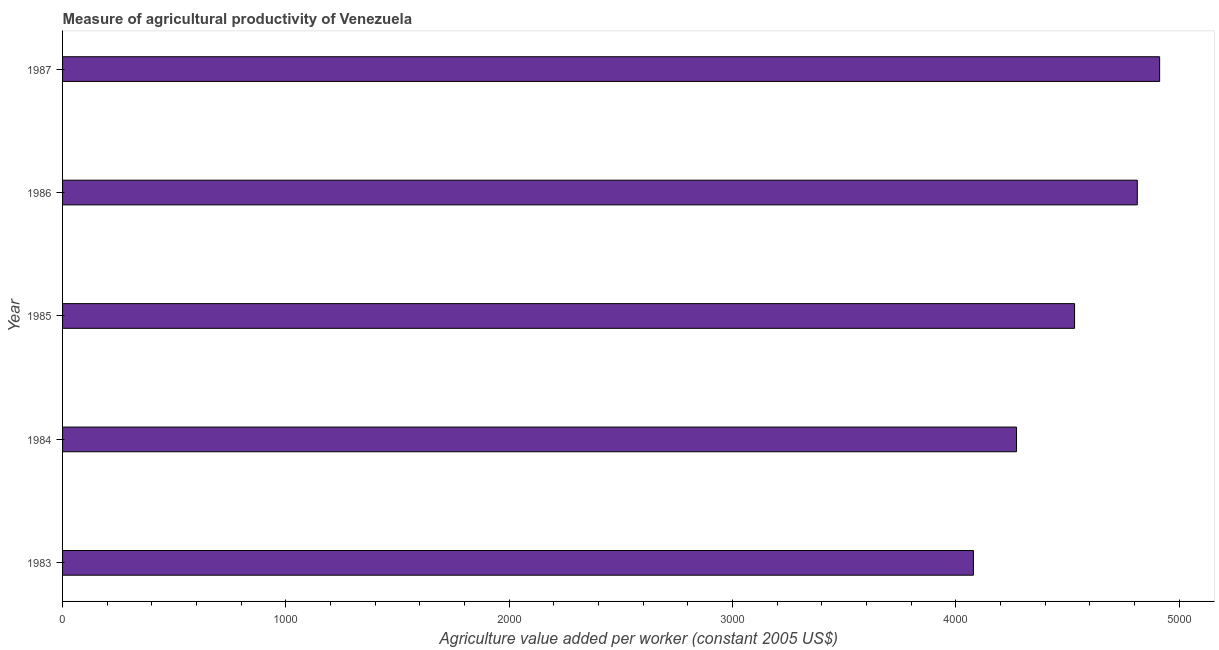Does the graph contain any zero values?
Offer a terse response. No. What is the title of the graph?
Your response must be concise. Measure of agricultural productivity of Venezuela. What is the label or title of the X-axis?
Ensure brevity in your answer.  Agriculture value added per worker (constant 2005 US$). What is the agriculture value added per worker in 1986?
Your answer should be very brief. 4812.26. Across all years, what is the maximum agriculture value added per worker?
Offer a terse response. 4912.27. Across all years, what is the minimum agriculture value added per worker?
Your answer should be very brief. 4078.45. What is the sum of the agriculture value added per worker?
Your answer should be compact. 2.26e+04. What is the difference between the agriculture value added per worker in 1983 and 1985?
Ensure brevity in your answer.  -452.94. What is the average agriculture value added per worker per year?
Keep it short and to the point. 4521.18. What is the median agriculture value added per worker?
Provide a succinct answer. 4531.39. In how many years, is the agriculture value added per worker greater than 600 US$?
Provide a short and direct response. 5. What is the ratio of the agriculture value added per worker in 1985 to that in 1986?
Provide a short and direct response. 0.94. What is the difference between the highest and the second highest agriculture value added per worker?
Offer a terse response. 100.02. Is the sum of the agriculture value added per worker in 1984 and 1986 greater than the maximum agriculture value added per worker across all years?
Keep it short and to the point. Yes. What is the difference between the highest and the lowest agriculture value added per worker?
Your answer should be compact. 833.82. In how many years, is the agriculture value added per worker greater than the average agriculture value added per worker taken over all years?
Offer a terse response. 3. How many bars are there?
Make the answer very short. 5. Are all the bars in the graph horizontal?
Offer a terse response. Yes. Are the values on the major ticks of X-axis written in scientific E-notation?
Make the answer very short. No. What is the Agriculture value added per worker (constant 2005 US$) in 1983?
Offer a terse response. 4078.45. What is the Agriculture value added per worker (constant 2005 US$) in 1984?
Make the answer very short. 4271.5. What is the Agriculture value added per worker (constant 2005 US$) in 1985?
Your response must be concise. 4531.39. What is the Agriculture value added per worker (constant 2005 US$) of 1986?
Give a very brief answer. 4812.26. What is the Agriculture value added per worker (constant 2005 US$) in 1987?
Make the answer very short. 4912.27. What is the difference between the Agriculture value added per worker (constant 2005 US$) in 1983 and 1984?
Your answer should be compact. -193.05. What is the difference between the Agriculture value added per worker (constant 2005 US$) in 1983 and 1985?
Provide a short and direct response. -452.93. What is the difference between the Agriculture value added per worker (constant 2005 US$) in 1983 and 1986?
Provide a short and direct response. -733.8. What is the difference between the Agriculture value added per worker (constant 2005 US$) in 1983 and 1987?
Your response must be concise. -833.82. What is the difference between the Agriculture value added per worker (constant 2005 US$) in 1984 and 1985?
Ensure brevity in your answer.  -259.88. What is the difference between the Agriculture value added per worker (constant 2005 US$) in 1984 and 1986?
Your answer should be compact. -540.75. What is the difference between the Agriculture value added per worker (constant 2005 US$) in 1984 and 1987?
Your response must be concise. -640.77. What is the difference between the Agriculture value added per worker (constant 2005 US$) in 1985 and 1986?
Provide a short and direct response. -280.87. What is the difference between the Agriculture value added per worker (constant 2005 US$) in 1985 and 1987?
Make the answer very short. -380.89. What is the difference between the Agriculture value added per worker (constant 2005 US$) in 1986 and 1987?
Keep it short and to the point. -100.02. What is the ratio of the Agriculture value added per worker (constant 2005 US$) in 1983 to that in 1984?
Offer a very short reply. 0.95. What is the ratio of the Agriculture value added per worker (constant 2005 US$) in 1983 to that in 1985?
Provide a short and direct response. 0.9. What is the ratio of the Agriculture value added per worker (constant 2005 US$) in 1983 to that in 1986?
Keep it short and to the point. 0.85. What is the ratio of the Agriculture value added per worker (constant 2005 US$) in 1983 to that in 1987?
Provide a succinct answer. 0.83. What is the ratio of the Agriculture value added per worker (constant 2005 US$) in 1984 to that in 1985?
Provide a succinct answer. 0.94. What is the ratio of the Agriculture value added per worker (constant 2005 US$) in 1984 to that in 1986?
Offer a very short reply. 0.89. What is the ratio of the Agriculture value added per worker (constant 2005 US$) in 1984 to that in 1987?
Ensure brevity in your answer.  0.87. What is the ratio of the Agriculture value added per worker (constant 2005 US$) in 1985 to that in 1986?
Your answer should be very brief. 0.94. What is the ratio of the Agriculture value added per worker (constant 2005 US$) in 1985 to that in 1987?
Offer a terse response. 0.92. What is the ratio of the Agriculture value added per worker (constant 2005 US$) in 1986 to that in 1987?
Ensure brevity in your answer.  0.98. 